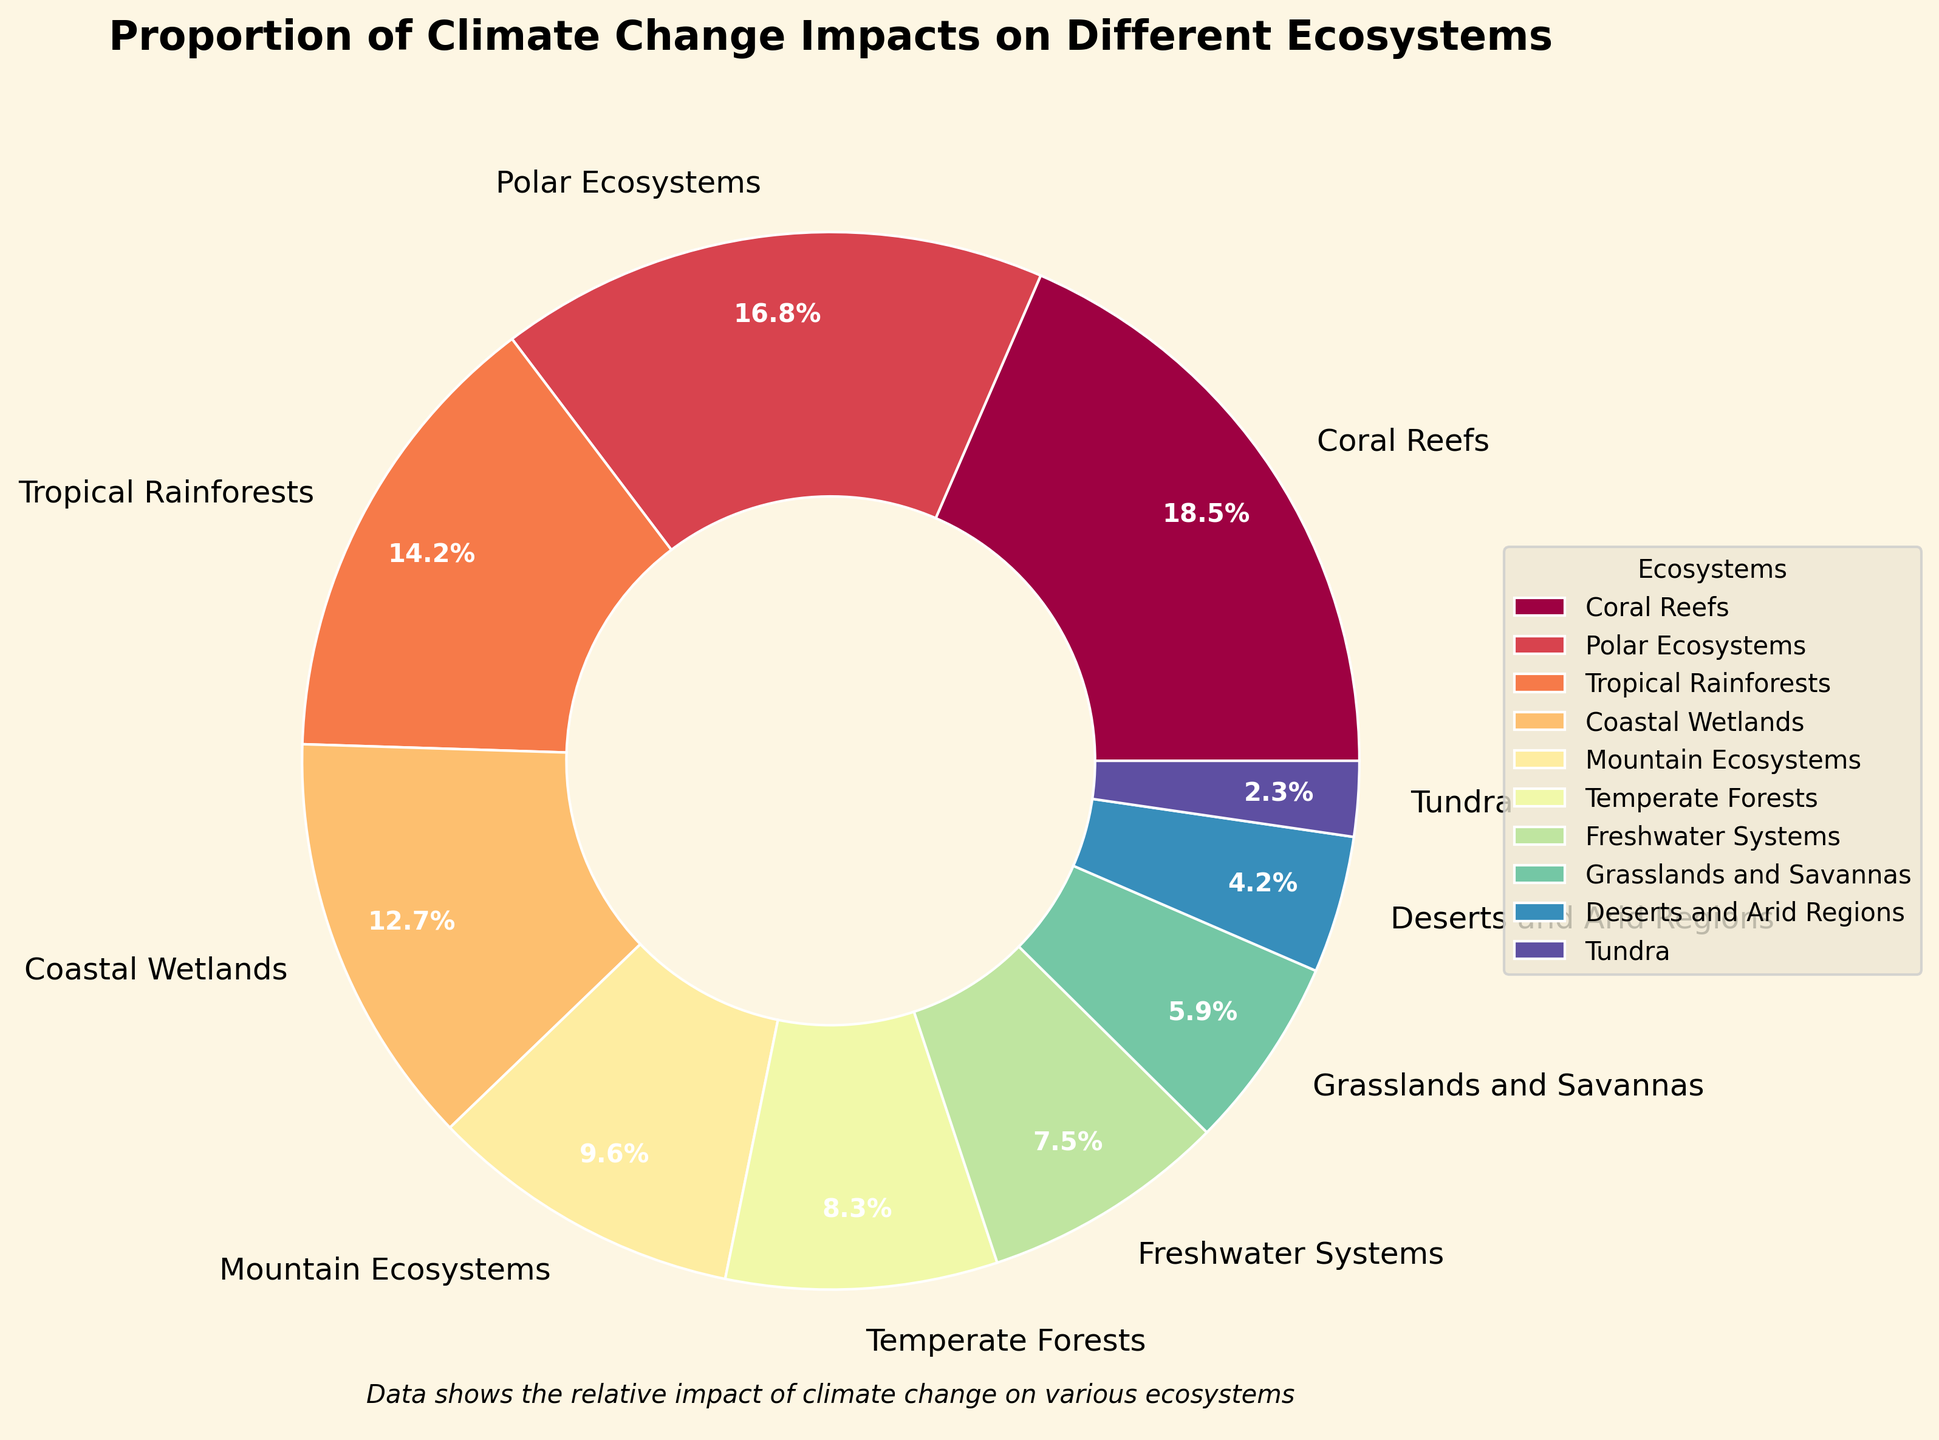What ecosystem has the highest impact proportion? Identify the section with the largest percentage in the pie chart. The label and percentage value show that Coral Reefs have the highest impact proportion at 18.5%.
Answer: Coral Reefs Which ecosystems have an impact proportion of less than 10%? Look for sections with percentages less than 10% in the chart. The labels show Mountain Ecosystems (9.6%), Temperate Forests (8.3%), Freshwater Systems (7.5%), Grasslands and Savannas (5.9%), Deserts and Arid Regions (4.2%), and Tundra (2.3%).
Answer: Mountain Ecosystems, Temperate Forests, Freshwater Systems, Grasslands and Savannas, Deserts and Arid Regions, Tundra How does the impact proportion of Polar Ecosystems compare to Tropical Rainforests? Compare the percentage values of Polar Ecosystems (16.8%) and Tropical Rainforests (14.2%) in the pie chart.
Answer: Polar Ecosystems have a higher impact proportion than Tropical Rainforests What is the combined impact proportion of Coastal Wetlands and Mountain Ecosystems? Add the percentages of Coastal Wetlands (12.7%) and Mountain Ecosystems (9.6%). The sum is 12.7 + 9.6 = 22.3%.
Answer: 22.3% Which ecosystem is represented by a section of the pie chart with a dark color, near the smaller impact proportions? Notice the visual attribute of darker colors, particularly among smaller sections. The smallest and darker section corresponds to Tundra, with 2.3%.
Answer: Tundra What is the difference in impact proportion between Coral Reefs and Deserts and Arid Regions? Subtract the percentage of Deserts and Arid Regions (4.2%) from Coral Reefs (18.5%). The difference is 18.5 - 4.2 = 14.3%.
Answer: 14.3% Which ecosystems together make up more than 50% of the total impact proportion? Add the percentages from the largest sections until the sum exceeds 50%. Coral Reefs (18.5%), Polar Ecosystems (16.8%), Tropical Rainforests (14.2%), and Coastal Wetlands (12.7%) together sum up to 62.2%.
Answer: Coral Reefs, Polar Ecosystems, Tropical Rainforests, Coastal Wetlands What is the impact proportion of ecosystems colored in warm tones (red, orange)? Identify sections with warm colors: Coral Reefs (18.5%) and Tropical Rainforests (14.2%). Add these percentages: 18.5 + 14.2 = 32.7%.
Answer: 32.7% How many ecosystems have an impact proportion greater than the median impact proportion? Find the median of the impact proportions, which is the average of the 5th and 6th data points: (9.6 + 8.3)/2 = 8.95%. Count ecosystems with proportions greater than 8.95%, which are 5 ecosystems.
Answer: 5 